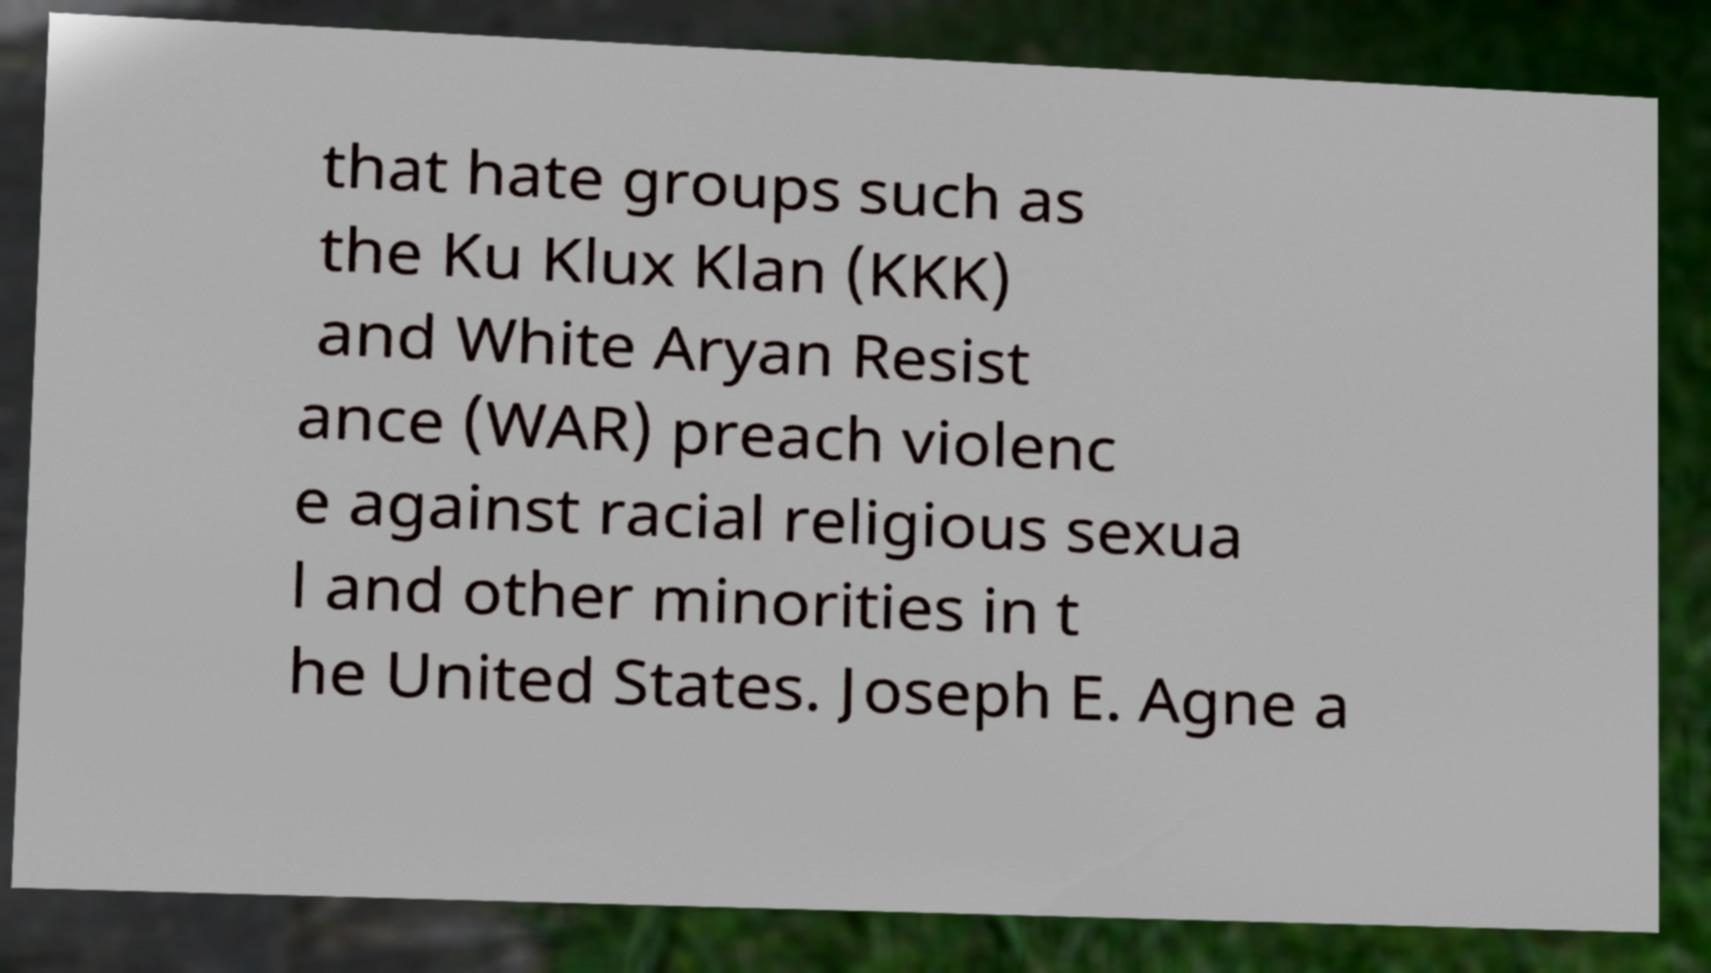Could you assist in decoding the text presented in this image and type it out clearly? that hate groups such as the Ku Klux Klan (KKK) and White Aryan Resist ance (WAR) preach violenc e against racial religious sexua l and other minorities in t he United States. Joseph E. Agne a 